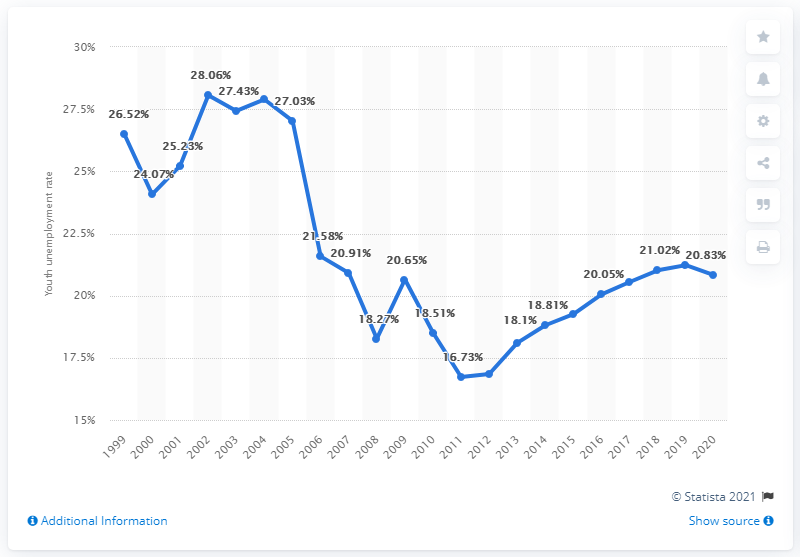Indicate a few pertinent items in this graphic. In 2020, the youth unemployment rate in Sri Lanka was 20.83%. 